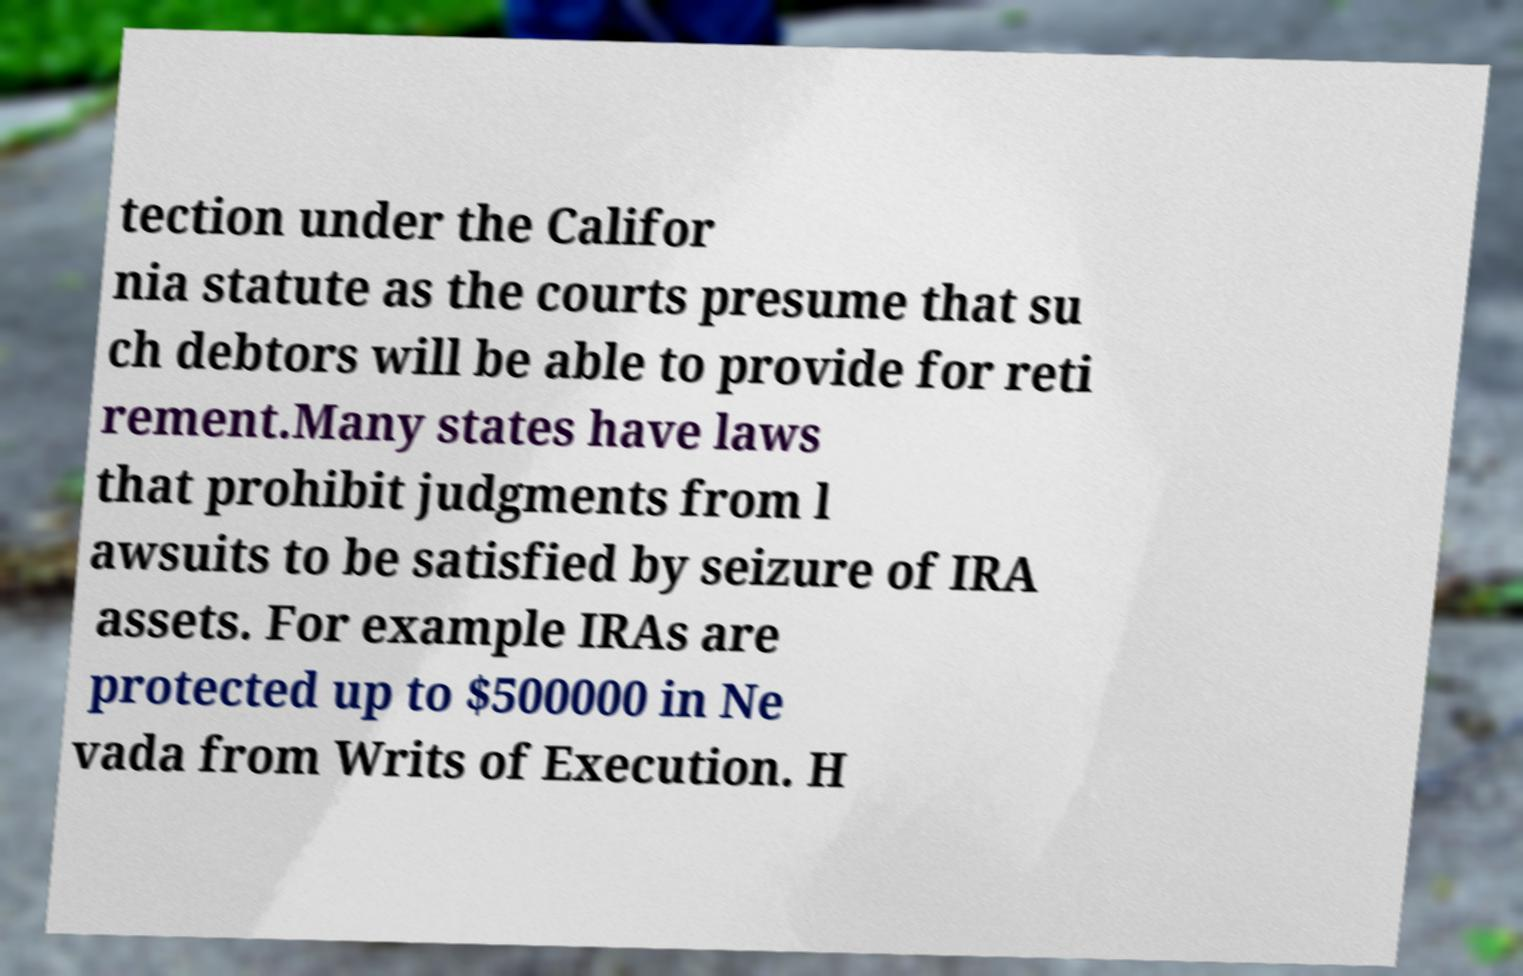Can you read and provide the text displayed in the image?This photo seems to have some interesting text. Can you extract and type it out for me? tection under the Califor nia statute as the courts presume that su ch debtors will be able to provide for reti rement.Many states have laws that prohibit judgments from l awsuits to be satisfied by seizure of IRA assets. For example IRAs are protected up to $500000 in Ne vada from Writs of Execution. H 